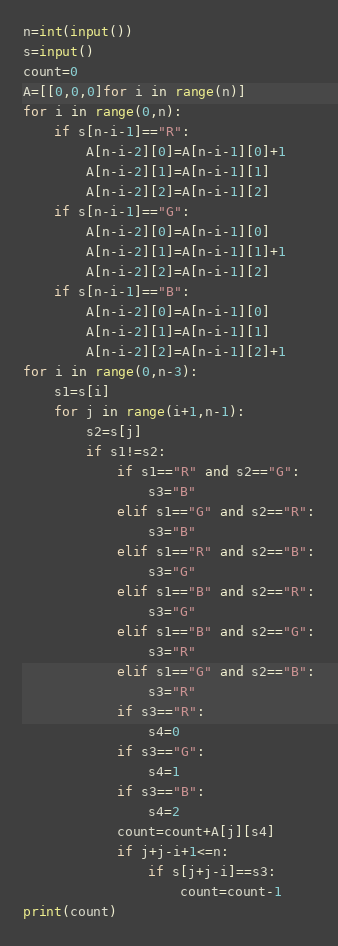<code> <loc_0><loc_0><loc_500><loc_500><_Python_>n=int(input())
s=input()
count=0
A=[[0,0,0]for i in range(n)]
for i in range(0,n):
    if s[n-i-1]=="R":
        A[n-i-2][0]=A[n-i-1][0]+1
        A[n-i-2][1]=A[n-i-1][1]
        A[n-i-2][2]=A[n-i-1][2]
    if s[n-i-1]=="G":
        A[n-i-2][0]=A[n-i-1][0]
        A[n-i-2][1]=A[n-i-1][1]+1
        A[n-i-2][2]=A[n-i-1][2]
    if s[n-i-1]=="B":
        A[n-i-2][0]=A[n-i-1][0]
        A[n-i-2][1]=A[n-i-1][1]
        A[n-i-2][2]=A[n-i-1][2]+1
for i in range(0,n-3):
    s1=s[i]
    for j in range(i+1,n-1):
        s2=s[j]
        if s1!=s2:
            if s1=="R" and s2=="G":
                s3="B"
            elif s1=="G" and s2=="R":
                s3="B"
            elif s1=="R" and s2=="B":
                s3="G"
            elif s1=="B" and s2=="R":
                s3="G"
            elif s1=="B" and s2=="G":
                s3="R"
            elif s1=="G" and s2=="B":
                s3="R"
            if s3=="R":
                s4=0
            if s3=="G":
                s4=1
            if s3=="B":
                s4=2
            count=count+A[j][s4]
            if j+j-i+1<=n: 
                if s[j+j-i]==s3:
                    count=count-1
print(count)</code> 